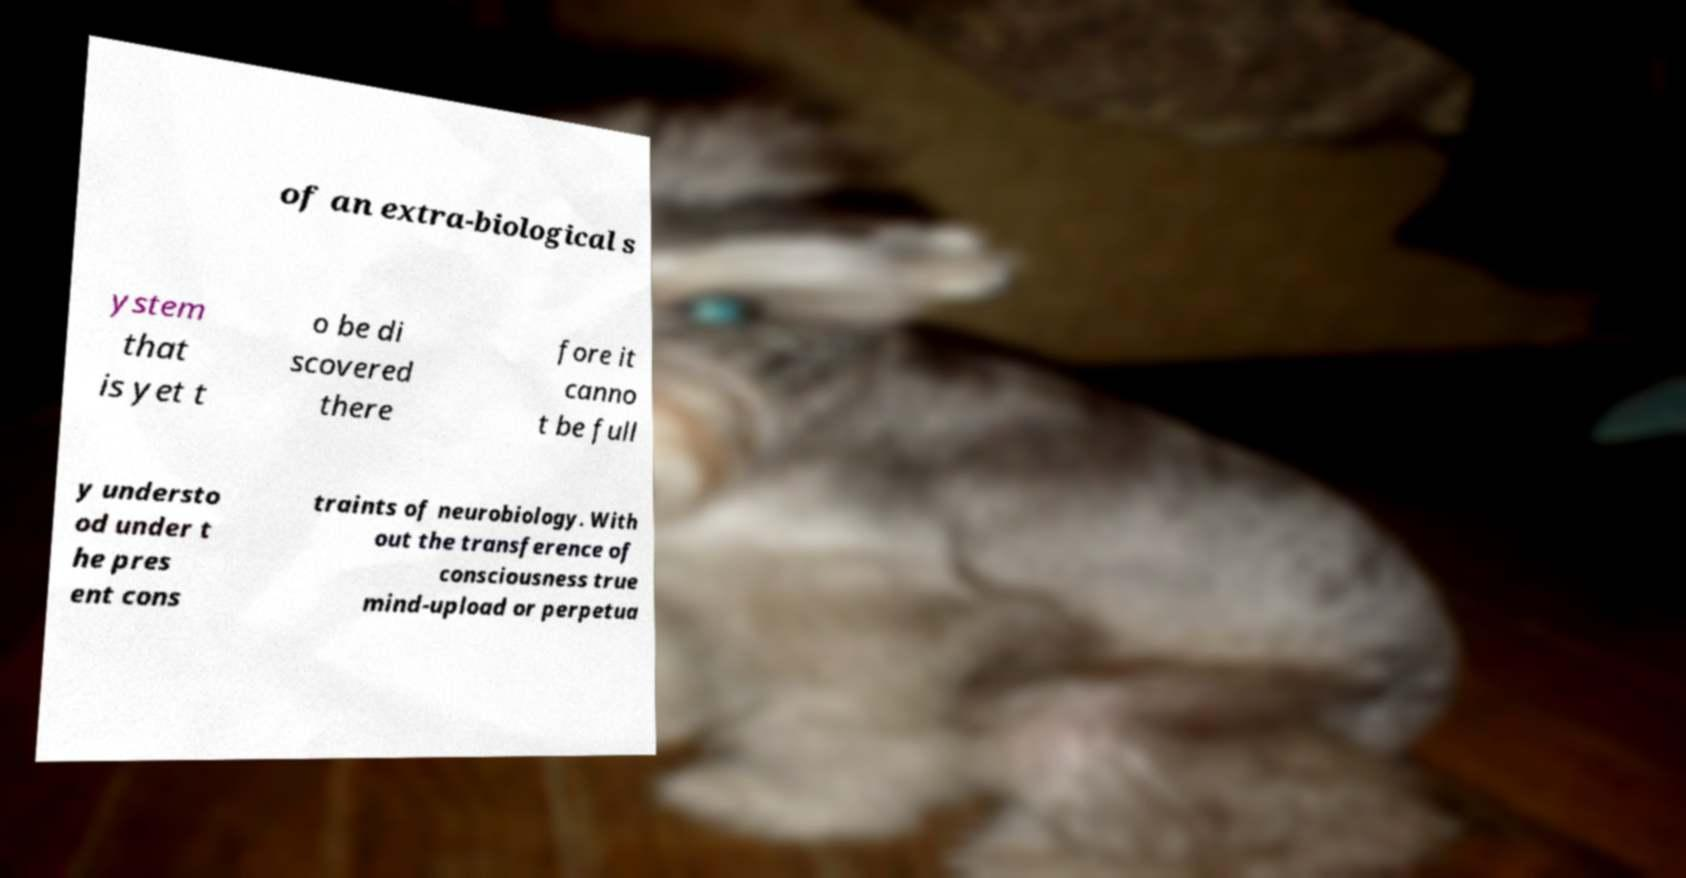What messages or text are displayed in this image? I need them in a readable, typed format. of an extra-biological s ystem that is yet t o be di scovered there fore it canno t be full y understo od under t he pres ent cons traints of neurobiology. With out the transference of consciousness true mind-upload or perpetua 